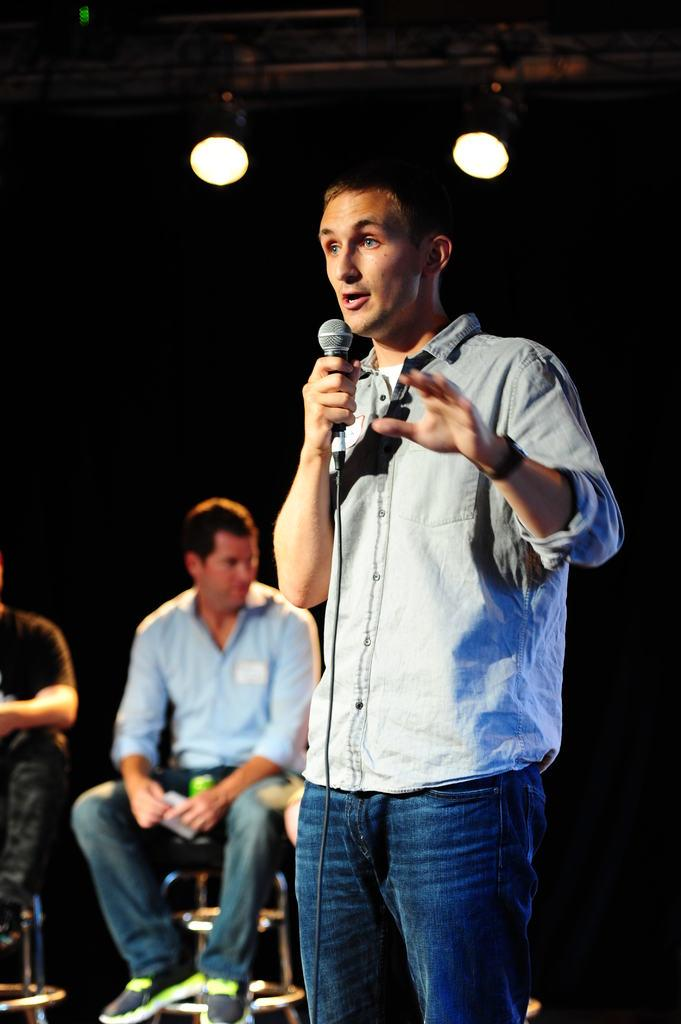What is the main subject of the image? The main subject of the image is a guy. What is the guy wearing? The guy is wearing a blue shirt and blue jeans. What is the guy holding in his right hand? The guy is holding a mic in his right hand. Can you describe the person sitting on a chair in the image? There is a person sitting on a chair in the image. What can be seen above the guy and the person sitting on the chair? There are two lights visible above them. How many friends does the guy have sitting next to him in the image? There is no indication of friends in the image; only the guy and the person sitting on a chair are visible. What type of form is the guy filling out in the image? There is no form present in the image; the guy is holding a mic in his right hand. 